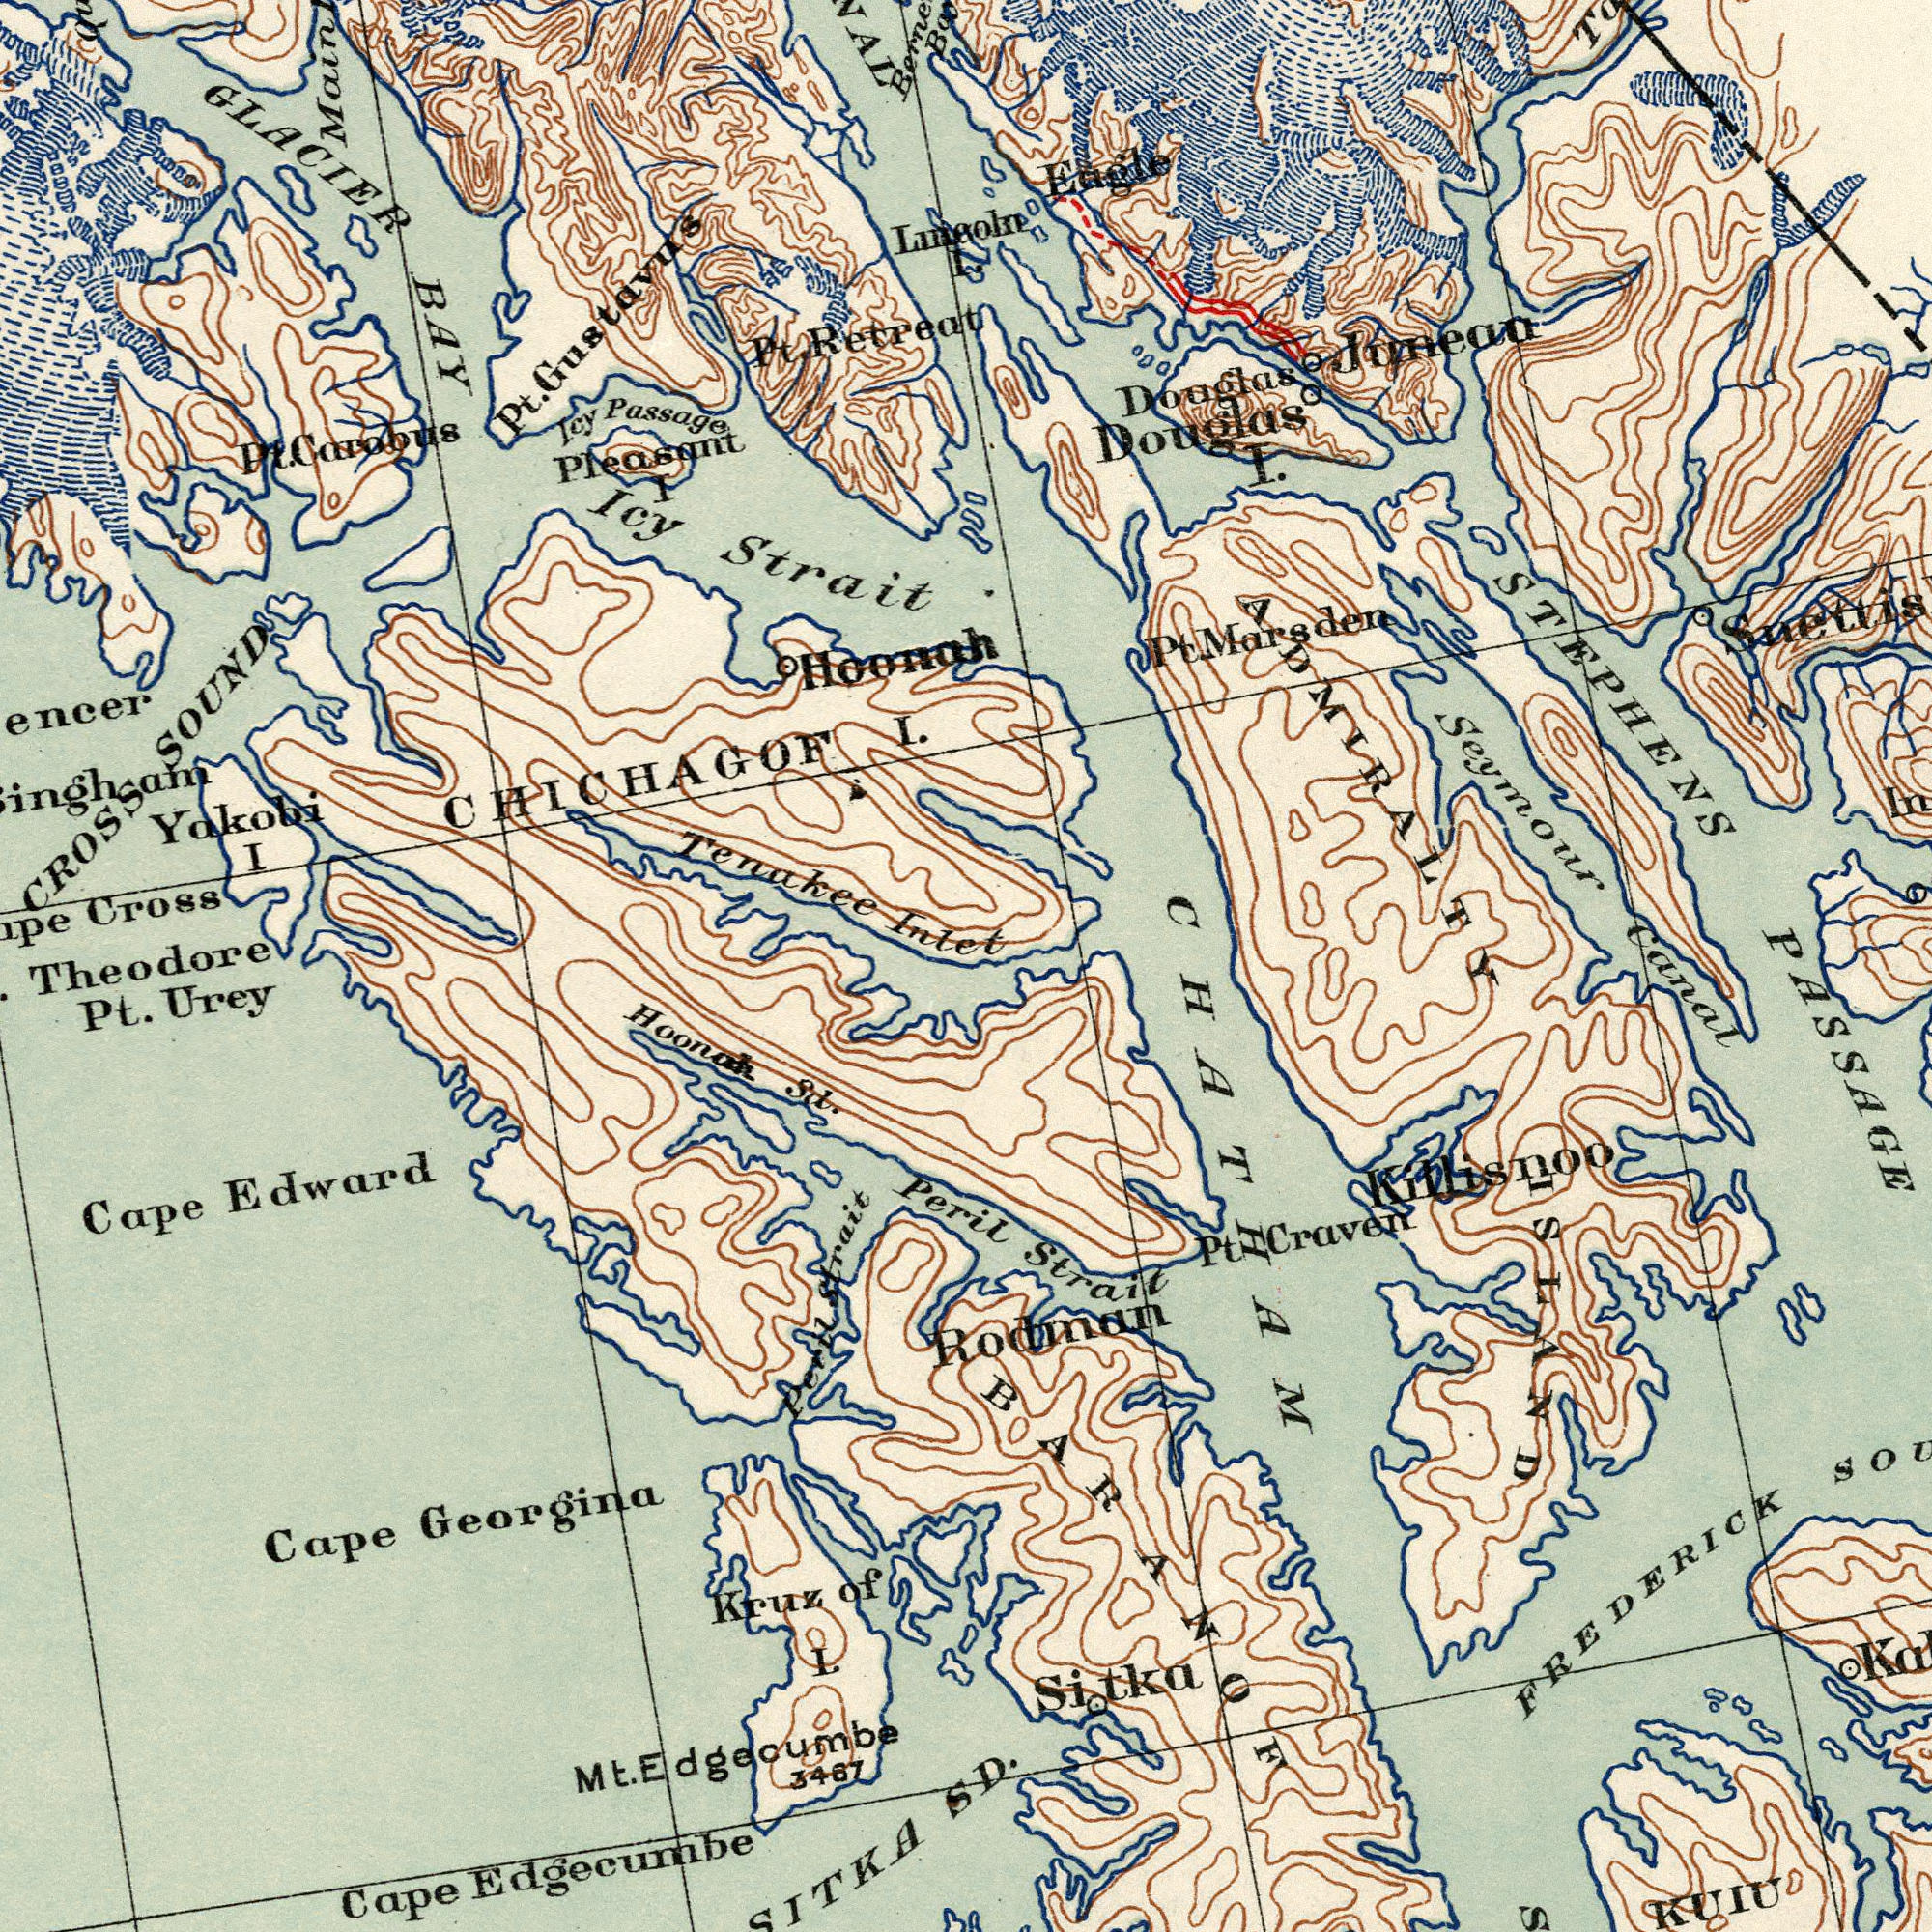What text can you see in the bottom-right section? Canal PASSAGE Strait SD. KUIU Rodman Pt Craven Sitka BARANOF FREDERICK CHATHAM Killisnoo ISLAND What text is visible in the upper-left corner? GLACIER BAY Cross Pleasant I Icy Strait Yakobi I Tenakee Inlet CROSS SOUND Hoonah Pt. Retreat CHICHAGOF I. Icy Passage Main Pt. Carobus Pt. Gustavns Theodore Lueoln I What text can you see in the bottom-left section? Pt. Urey Cape Edward Cape Edgecumbe Kruz of L Hoonah Sd. Cape Georgina 3467 Peril Mt. Edgecumbe Peril Strait What text can you see in the top-right section? Juneaa Douglas I. Eagle Seymour STEPHENS Douglas Pt. Marsden ADMIRALTY 